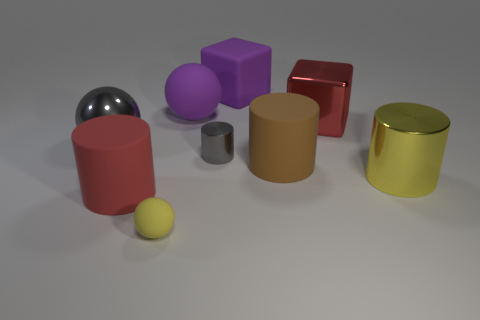Subtract all purple blocks. How many blocks are left? 1 Subtract all big yellow shiny cylinders. How many cylinders are left? 3 Subtract 1 blocks. How many blocks are left? 1 Add 1 blue blocks. How many objects exist? 10 Subtract 0 brown cubes. How many objects are left? 9 Subtract all cylinders. How many objects are left? 5 Subtract all yellow spheres. Subtract all purple blocks. How many spheres are left? 2 Subtract all blue cylinders. How many yellow spheres are left? 1 Subtract all gray cylinders. Subtract all metal balls. How many objects are left? 7 Add 6 large purple rubber things. How many large purple rubber things are left? 8 